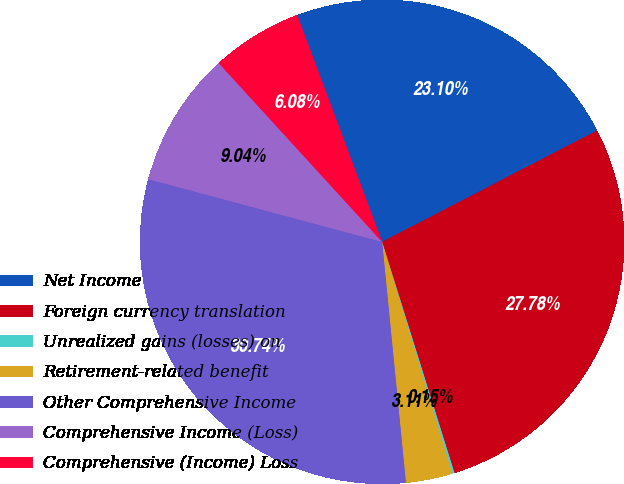Convert chart to OTSL. <chart><loc_0><loc_0><loc_500><loc_500><pie_chart><fcel>Net Income<fcel>Foreign currency translation<fcel>Unrealized gains (losses) on<fcel>Retirement-related benefit<fcel>Other Comprehensive Income<fcel>Comprehensive Income (Loss)<fcel>Comprehensive (Income) Loss<nl><fcel>23.1%<fcel>27.78%<fcel>0.15%<fcel>3.11%<fcel>30.74%<fcel>9.04%<fcel>6.08%<nl></chart> 